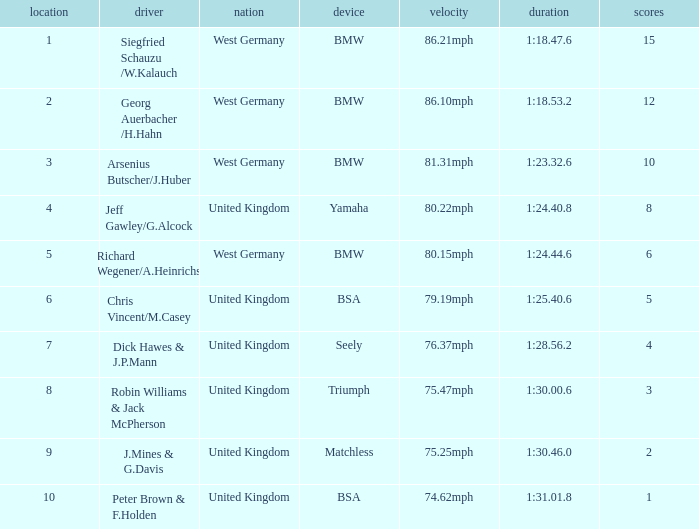Which place has points larger than 1, a bmw machine, and a time of 1:18.47.6? 1.0. 